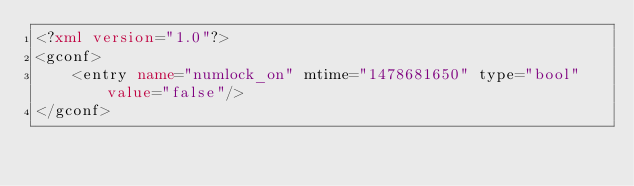<code> <loc_0><loc_0><loc_500><loc_500><_XML_><?xml version="1.0"?>
<gconf>
	<entry name="numlock_on" mtime="1478681650" type="bool" value="false"/>
</gconf>
</code> 